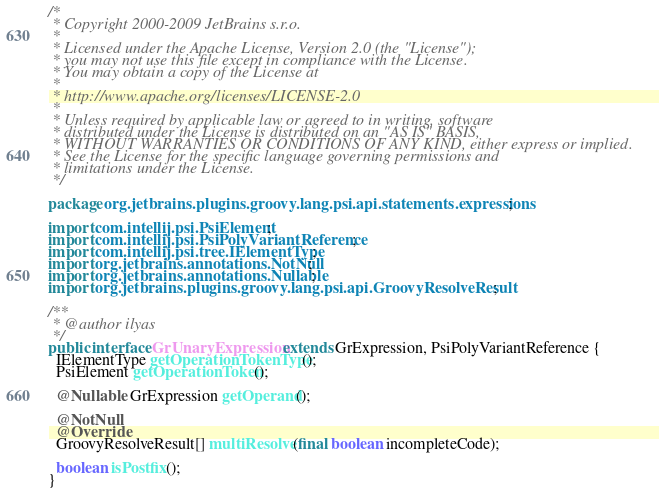<code> <loc_0><loc_0><loc_500><loc_500><_Java_>/*
 * Copyright 2000-2009 JetBrains s.r.o.
 *
 * Licensed under the Apache License, Version 2.0 (the "License");
 * you may not use this file except in compliance with the License.
 * You may obtain a copy of the License at
 *
 * http://www.apache.org/licenses/LICENSE-2.0
 *
 * Unless required by applicable law or agreed to in writing, software
 * distributed under the License is distributed on an "AS IS" BASIS,
 * WITHOUT WARRANTIES OR CONDITIONS OF ANY KIND, either express or implied.
 * See the License for the specific language governing permissions and
 * limitations under the License.
 */

package org.jetbrains.plugins.groovy.lang.psi.api.statements.expressions;

import com.intellij.psi.PsiElement;
import com.intellij.psi.PsiPolyVariantReference;
import com.intellij.psi.tree.IElementType;
import org.jetbrains.annotations.NotNull;
import org.jetbrains.annotations.Nullable;
import org.jetbrains.plugins.groovy.lang.psi.api.GroovyResolveResult;

/**
 * @author ilyas
 */
public interface GrUnaryExpression extends GrExpression, PsiPolyVariantReference {
  IElementType getOperationTokenType();
  PsiElement getOperationToken();

  @Nullable GrExpression getOperand();

  @NotNull
  @Override
  GroovyResolveResult[] multiResolve(final boolean incompleteCode);

  boolean isPostfix();
}
</code> 